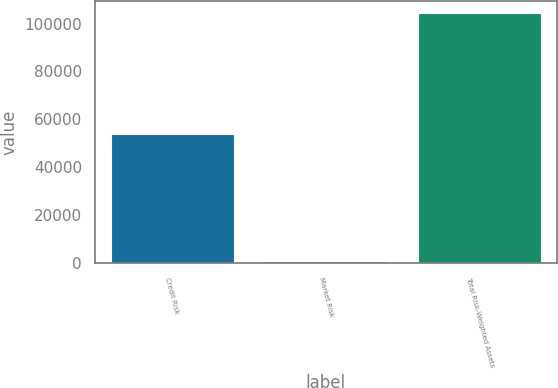<chart> <loc_0><loc_0><loc_500><loc_500><bar_chart><fcel>Credit Risk<fcel>Market Risk<fcel>Total Risk-Weighted Assets<nl><fcel>54069<fcel>1117<fcel>104265<nl></chart> 